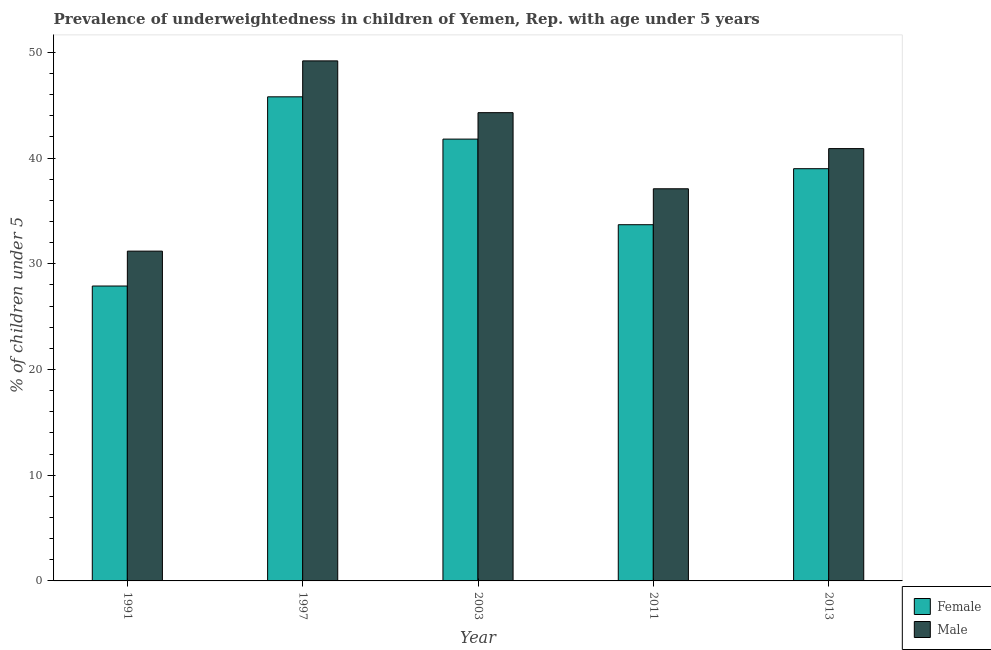Are the number of bars per tick equal to the number of legend labels?
Give a very brief answer. Yes. What is the label of the 5th group of bars from the left?
Offer a terse response. 2013. In how many cases, is the number of bars for a given year not equal to the number of legend labels?
Provide a succinct answer. 0. What is the percentage of underweighted male children in 1997?
Offer a terse response. 49.2. Across all years, what is the maximum percentage of underweighted male children?
Your response must be concise. 49.2. Across all years, what is the minimum percentage of underweighted female children?
Your response must be concise. 27.9. In which year was the percentage of underweighted female children maximum?
Provide a short and direct response. 1997. In which year was the percentage of underweighted female children minimum?
Offer a terse response. 1991. What is the total percentage of underweighted male children in the graph?
Keep it short and to the point. 202.7. What is the difference between the percentage of underweighted female children in 1997 and that in 2013?
Your answer should be very brief. 6.8. What is the difference between the percentage of underweighted female children in 1997 and the percentage of underweighted male children in 2003?
Make the answer very short. 4. What is the average percentage of underweighted male children per year?
Provide a short and direct response. 40.54. What is the ratio of the percentage of underweighted male children in 2003 to that in 2013?
Keep it short and to the point. 1.08. Is the difference between the percentage of underweighted female children in 2003 and 2013 greater than the difference between the percentage of underweighted male children in 2003 and 2013?
Make the answer very short. No. What is the difference between the highest and the second highest percentage of underweighted female children?
Ensure brevity in your answer.  4. What is the difference between the highest and the lowest percentage of underweighted male children?
Offer a very short reply. 18. Is the sum of the percentage of underweighted female children in 1991 and 2011 greater than the maximum percentage of underweighted male children across all years?
Your response must be concise. Yes. What does the 2nd bar from the left in 1991 represents?
Offer a terse response. Male. What does the 2nd bar from the right in 2013 represents?
Your answer should be compact. Female. Are all the bars in the graph horizontal?
Make the answer very short. No. Are the values on the major ticks of Y-axis written in scientific E-notation?
Make the answer very short. No. How many legend labels are there?
Provide a succinct answer. 2. What is the title of the graph?
Ensure brevity in your answer.  Prevalence of underweightedness in children of Yemen, Rep. with age under 5 years. Does "ODA received" appear as one of the legend labels in the graph?
Keep it short and to the point. No. What is the label or title of the X-axis?
Your response must be concise. Year. What is the label or title of the Y-axis?
Offer a terse response.  % of children under 5. What is the  % of children under 5 of Female in 1991?
Give a very brief answer. 27.9. What is the  % of children under 5 of Male in 1991?
Offer a terse response. 31.2. What is the  % of children under 5 in Female in 1997?
Provide a short and direct response. 45.8. What is the  % of children under 5 of Male in 1997?
Give a very brief answer. 49.2. What is the  % of children under 5 in Female in 2003?
Keep it short and to the point. 41.8. What is the  % of children under 5 in Male in 2003?
Your response must be concise. 44.3. What is the  % of children under 5 in Female in 2011?
Provide a succinct answer. 33.7. What is the  % of children under 5 of Male in 2011?
Provide a succinct answer. 37.1. What is the  % of children under 5 of Male in 2013?
Make the answer very short. 40.9. Across all years, what is the maximum  % of children under 5 of Female?
Make the answer very short. 45.8. Across all years, what is the maximum  % of children under 5 of Male?
Keep it short and to the point. 49.2. Across all years, what is the minimum  % of children under 5 of Female?
Make the answer very short. 27.9. Across all years, what is the minimum  % of children under 5 of Male?
Ensure brevity in your answer.  31.2. What is the total  % of children under 5 of Female in the graph?
Ensure brevity in your answer.  188.2. What is the total  % of children under 5 of Male in the graph?
Give a very brief answer. 202.7. What is the difference between the  % of children under 5 in Female in 1991 and that in 1997?
Your response must be concise. -17.9. What is the difference between the  % of children under 5 in Female in 1991 and that in 2013?
Provide a succinct answer. -11.1. What is the difference between the  % of children under 5 in Male in 1997 and that in 2003?
Provide a short and direct response. 4.9. What is the difference between the  % of children under 5 of Female in 1997 and that in 2011?
Ensure brevity in your answer.  12.1. What is the difference between the  % of children under 5 of Male in 1997 and that in 2011?
Make the answer very short. 12.1. What is the difference between the  % of children under 5 of Female in 1997 and that in 2013?
Offer a terse response. 6.8. What is the difference between the  % of children under 5 of Male in 1997 and that in 2013?
Keep it short and to the point. 8.3. What is the difference between the  % of children under 5 of Male in 2003 and that in 2011?
Your answer should be very brief. 7.2. What is the difference between the  % of children under 5 of Female in 2003 and that in 2013?
Offer a very short reply. 2.8. What is the difference between the  % of children under 5 of Male in 2003 and that in 2013?
Give a very brief answer. 3.4. What is the difference between the  % of children under 5 in Female in 2011 and that in 2013?
Your answer should be compact. -5.3. What is the difference between the  % of children under 5 in Male in 2011 and that in 2013?
Provide a succinct answer. -3.8. What is the difference between the  % of children under 5 in Female in 1991 and the  % of children under 5 in Male in 1997?
Your answer should be very brief. -21.3. What is the difference between the  % of children under 5 of Female in 1991 and the  % of children under 5 of Male in 2003?
Your answer should be very brief. -16.4. What is the difference between the  % of children under 5 in Female in 1991 and the  % of children under 5 in Male in 2013?
Keep it short and to the point. -13. What is the difference between the  % of children under 5 in Female in 1997 and the  % of children under 5 in Male in 2003?
Make the answer very short. 1.5. What is the difference between the  % of children under 5 in Female in 1997 and the  % of children under 5 in Male in 2013?
Offer a very short reply. 4.9. What is the difference between the  % of children under 5 of Female in 2003 and the  % of children under 5 of Male in 2011?
Ensure brevity in your answer.  4.7. What is the difference between the  % of children under 5 of Female in 2003 and the  % of children under 5 of Male in 2013?
Your answer should be compact. 0.9. What is the difference between the  % of children under 5 in Female in 2011 and the  % of children under 5 in Male in 2013?
Ensure brevity in your answer.  -7.2. What is the average  % of children under 5 in Female per year?
Ensure brevity in your answer.  37.64. What is the average  % of children under 5 in Male per year?
Your answer should be very brief. 40.54. In the year 1991, what is the difference between the  % of children under 5 of Female and  % of children under 5 of Male?
Offer a very short reply. -3.3. In the year 2003, what is the difference between the  % of children under 5 of Female and  % of children under 5 of Male?
Your response must be concise. -2.5. In the year 2011, what is the difference between the  % of children under 5 in Female and  % of children under 5 in Male?
Your answer should be compact. -3.4. In the year 2013, what is the difference between the  % of children under 5 in Female and  % of children under 5 in Male?
Make the answer very short. -1.9. What is the ratio of the  % of children under 5 in Female in 1991 to that in 1997?
Offer a very short reply. 0.61. What is the ratio of the  % of children under 5 in Male in 1991 to that in 1997?
Give a very brief answer. 0.63. What is the ratio of the  % of children under 5 in Female in 1991 to that in 2003?
Make the answer very short. 0.67. What is the ratio of the  % of children under 5 in Male in 1991 to that in 2003?
Offer a very short reply. 0.7. What is the ratio of the  % of children under 5 in Female in 1991 to that in 2011?
Provide a succinct answer. 0.83. What is the ratio of the  % of children under 5 of Male in 1991 to that in 2011?
Offer a very short reply. 0.84. What is the ratio of the  % of children under 5 in Female in 1991 to that in 2013?
Keep it short and to the point. 0.72. What is the ratio of the  % of children under 5 of Male in 1991 to that in 2013?
Give a very brief answer. 0.76. What is the ratio of the  % of children under 5 of Female in 1997 to that in 2003?
Provide a succinct answer. 1.1. What is the ratio of the  % of children under 5 of Male in 1997 to that in 2003?
Your response must be concise. 1.11. What is the ratio of the  % of children under 5 in Female in 1997 to that in 2011?
Make the answer very short. 1.36. What is the ratio of the  % of children under 5 of Male in 1997 to that in 2011?
Give a very brief answer. 1.33. What is the ratio of the  % of children under 5 of Female in 1997 to that in 2013?
Your response must be concise. 1.17. What is the ratio of the  % of children under 5 in Male in 1997 to that in 2013?
Keep it short and to the point. 1.2. What is the ratio of the  % of children under 5 of Female in 2003 to that in 2011?
Your answer should be very brief. 1.24. What is the ratio of the  % of children under 5 of Male in 2003 to that in 2011?
Offer a terse response. 1.19. What is the ratio of the  % of children under 5 of Female in 2003 to that in 2013?
Give a very brief answer. 1.07. What is the ratio of the  % of children under 5 of Male in 2003 to that in 2013?
Your answer should be compact. 1.08. What is the ratio of the  % of children under 5 of Female in 2011 to that in 2013?
Your answer should be compact. 0.86. What is the ratio of the  % of children under 5 of Male in 2011 to that in 2013?
Your answer should be compact. 0.91. What is the difference between the highest and the second highest  % of children under 5 of Female?
Ensure brevity in your answer.  4. What is the difference between the highest and the second highest  % of children under 5 of Male?
Keep it short and to the point. 4.9. What is the difference between the highest and the lowest  % of children under 5 in Female?
Your answer should be very brief. 17.9. What is the difference between the highest and the lowest  % of children under 5 in Male?
Your answer should be very brief. 18. 